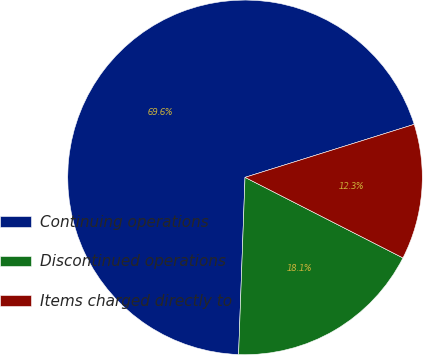Convert chart. <chart><loc_0><loc_0><loc_500><loc_500><pie_chart><fcel>Continuing operations<fcel>Discontinued operations<fcel>Items charged directly to<nl><fcel>69.59%<fcel>18.07%<fcel>12.34%<nl></chart> 